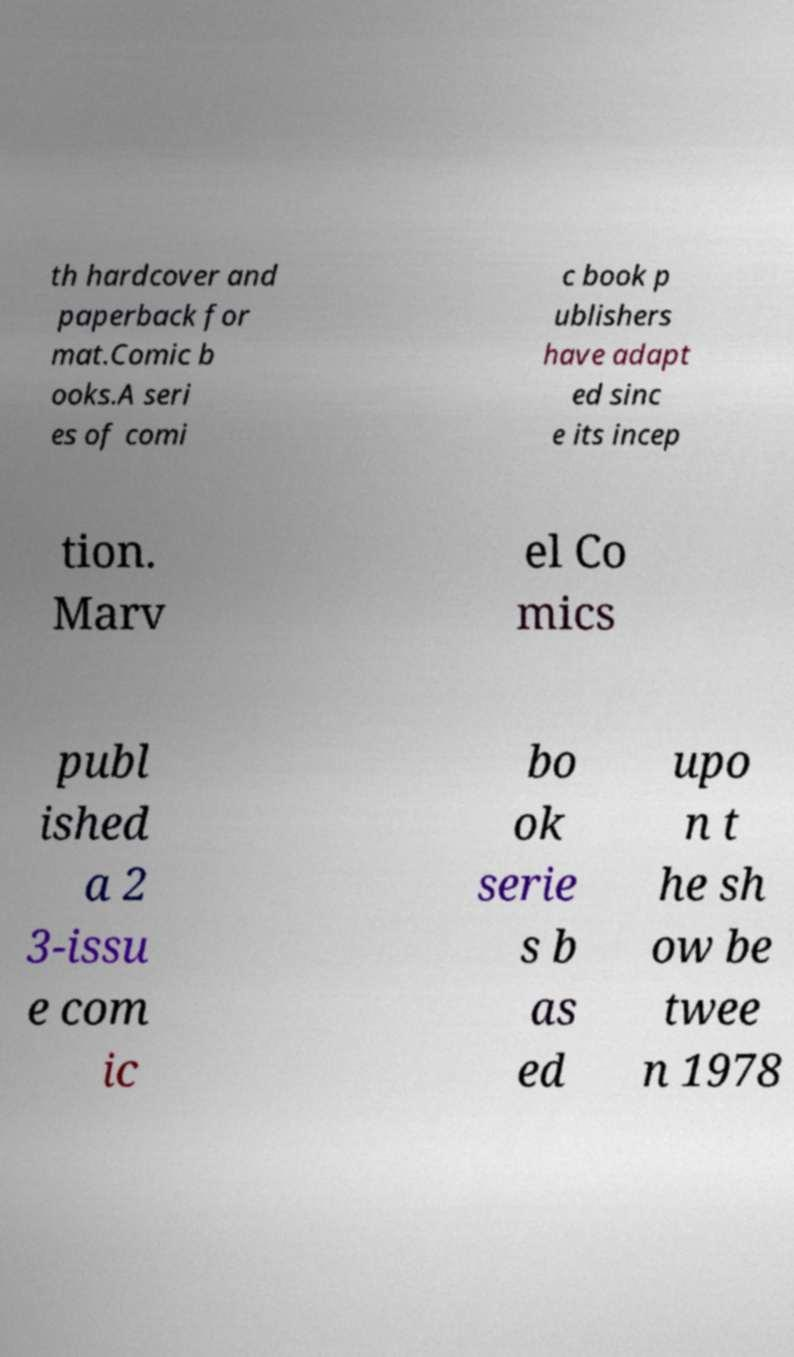Could you assist in decoding the text presented in this image and type it out clearly? th hardcover and paperback for mat.Comic b ooks.A seri es of comi c book p ublishers have adapt ed sinc e its incep tion. Marv el Co mics publ ished a 2 3-issu e com ic bo ok serie s b as ed upo n t he sh ow be twee n 1978 